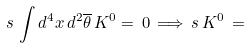Convert formula to latex. <formula><loc_0><loc_0><loc_500><loc_500>s \, \int d ^ { 4 } x \, d ^ { 2 } \overline { \theta } \, K ^ { 0 } = \, 0 \, \Longrightarrow \, s \, K ^ { 0 } \, = \,</formula> 